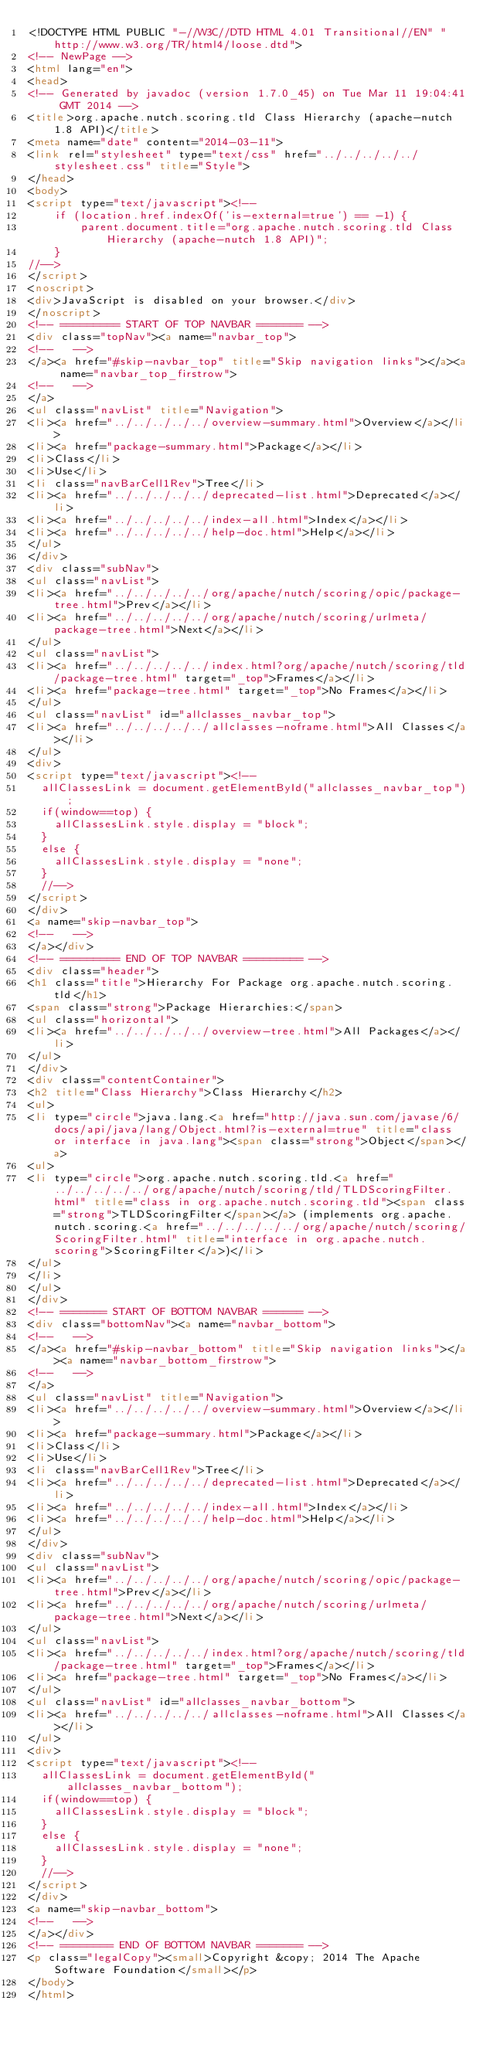<code> <loc_0><loc_0><loc_500><loc_500><_HTML_><!DOCTYPE HTML PUBLIC "-//W3C//DTD HTML 4.01 Transitional//EN" "http://www.w3.org/TR/html4/loose.dtd">
<!-- NewPage -->
<html lang="en">
<head>
<!-- Generated by javadoc (version 1.7.0_45) on Tue Mar 11 19:04:41 GMT 2014 -->
<title>org.apache.nutch.scoring.tld Class Hierarchy (apache-nutch 1.8 API)</title>
<meta name="date" content="2014-03-11">
<link rel="stylesheet" type="text/css" href="../../../../../stylesheet.css" title="Style">
</head>
<body>
<script type="text/javascript"><!--
    if (location.href.indexOf('is-external=true') == -1) {
        parent.document.title="org.apache.nutch.scoring.tld Class Hierarchy (apache-nutch 1.8 API)";
    }
//-->
</script>
<noscript>
<div>JavaScript is disabled on your browser.</div>
</noscript>
<!-- ========= START OF TOP NAVBAR ======= -->
<div class="topNav"><a name="navbar_top">
<!--   -->
</a><a href="#skip-navbar_top" title="Skip navigation links"></a><a name="navbar_top_firstrow">
<!--   -->
</a>
<ul class="navList" title="Navigation">
<li><a href="../../../../../overview-summary.html">Overview</a></li>
<li><a href="package-summary.html">Package</a></li>
<li>Class</li>
<li>Use</li>
<li class="navBarCell1Rev">Tree</li>
<li><a href="../../../../../deprecated-list.html">Deprecated</a></li>
<li><a href="../../../../../index-all.html">Index</a></li>
<li><a href="../../../../../help-doc.html">Help</a></li>
</ul>
</div>
<div class="subNav">
<ul class="navList">
<li><a href="../../../../../org/apache/nutch/scoring/opic/package-tree.html">Prev</a></li>
<li><a href="../../../../../org/apache/nutch/scoring/urlmeta/package-tree.html">Next</a></li>
</ul>
<ul class="navList">
<li><a href="../../../../../index.html?org/apache/nutch/scoring/tld/package-tree.html" target="_top">Frames</a></li>
<li><a href="package-tree.html" target="_top">No Frames</a></li>
</ul>
<ul class="navList" id="allclasses_navbar_top">
<li><a href="../../../../../allclasses-noframe.html">All Classes</a></li>
</ul>
<div>
<script type="text/javascript"><!--
  allClassesLink = document.getElementById("allclasses_navbar_top");
  if(window==top) {
    allClassesLink.style.display = "block";
  }
  else {
    allClassesLink.style.display = "none";
  }
  //-->
</script>
</div>
<a name="skip-navbar_top">
<!--   -->
</a></div>
<!-- ========= END OF TOP NAVBAR ========= -->
<div class="header">
<h1 class="title">Hierarchy For Package org.apache.nutch.scoring.tld</h1>
<span class="strong">Package Hierarchies:</span>
<ul class="horizontal">
<li><a href="../../../../../overview-tree.html">All Packages</a></li>
</ul>
</div>
<div class="contentContainer">
<h2 title="Class Hierarchy">Class Hierarchy</h2>
<ul>
<li type="circle">java.lang.<a href="http://java.sun.com/javase/6/docs/api/java/lang/Object.html?is-external=true" title="class or interface in java.lang"><span class="strong">Object</span></a>
<ul>
<li type="circle">org.apache.nutch.scoring.tld.<a href="../../../../../org/apache/nutch/scoring/tld/TLDScoringFilter.html" title="class in org.apache.nutch.scoring.tld"><span class="strong">TLDScoringFilter</span></a> (implements org.apache.nutch.scoring.<a href="../../../../../org/apache/nutch/scoring/ScoringFilter.html" title="interface in org.apache.nutch.scoring">ScoringFilter</a>)</li>
</ul>
</li>
</ul>
</div>
<!-- ======= START OF BOTTOM NAVBAR ====== -->
<div class="bottomNav"><a name="navbar_bottom">
<!--   -->
</a><a href="#skip-navbar_bottom" title="Skip navigation links"></a><a name="navbar_bottom_firstrow">
<!--   -->
</a>
<ul class="navList" title="Navigation">
<li><a href="../../../../../overview-summary.html">Overview</a></li>
<li><a href="package-summary.html">Package</a></li>
<li>Class</li>
<li>Use</li>
<li class="navBarCell1Rev">Tree</li>
<li><a href="../../../../../deprecated-list.html">Deprecated</a></li>
<li><a href="../../../../../index-all.html">Index</a></li>
<li><a href="../../../../../help-doc.html">Help</a></li>
</ul>
</div>
<div class="subNav">
<ul class="navList">
<li><a href="../../../../../org/apache/nutch/scoring/opic/package-tree.html">Prev</a></li>
<li><a href="../../../../../org/apache/nutch/scoring/urlmeta/package-tree.html">Next</a></li>
</ul>
<ul class="navList">
<li><a href="../../../../../index.html?org/apache/nutch/scoring/tld/package-tree.html" target="_top">Frames</a></li>
<li><a href="package-tree.html" target="_top">No Frames</a></li>
</ul>
<ul class="navList" id="allclasses_navbar_bottom">
<li><a href="../../../../../allclasses-noframe.html">All Classes</a></li>
</ul>
<div>
<script type="text/javascript"><!--
  allClassesLink = document.getElementById("allclasses_navbar_bottom");
  if(window==top) {
    allClassesLink.style.display = "block";
  }
  else {
    allClassesLink.style.display = "none";
  }
  //-->
</script>
</div>
<a name="skip-navbar_bottom">
<!--   -->
</a></div>
<!-- ======== END OF BOTTOM NAVBAR ======= -->
<p class="legalCopy"><small>Copyright &copy; 2014 The Apache Software Foundation</small></p>
</body>
</html>
</code> 